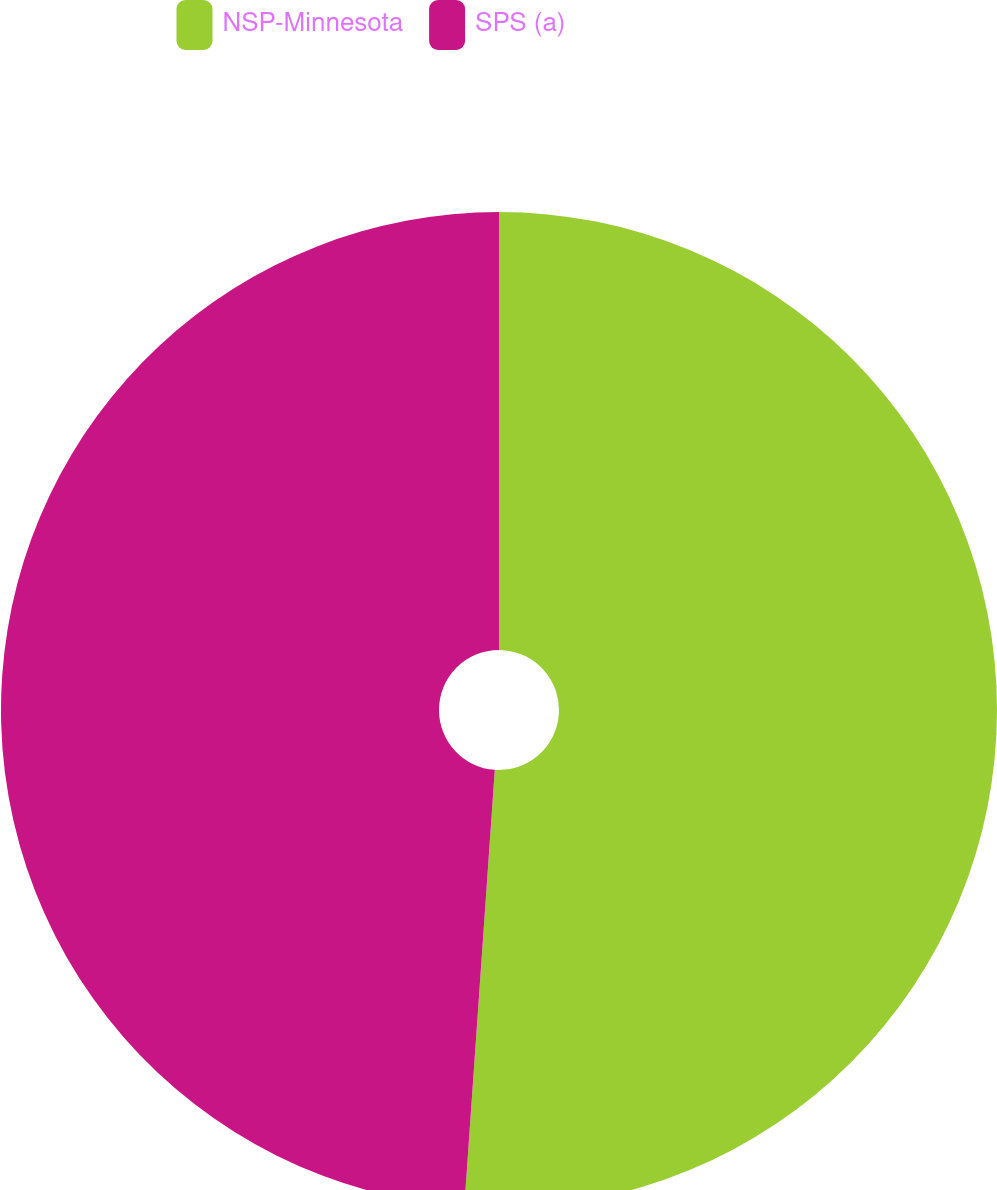Convert chart to OTSL. <chart><loc_0><loc_0><loc_500><loc_500><pie_chart><fcel>NSP-Minnesota<fcel>SPS (a)<nl><fcel>51.11%<fcel>48.89%<nl></chart> 